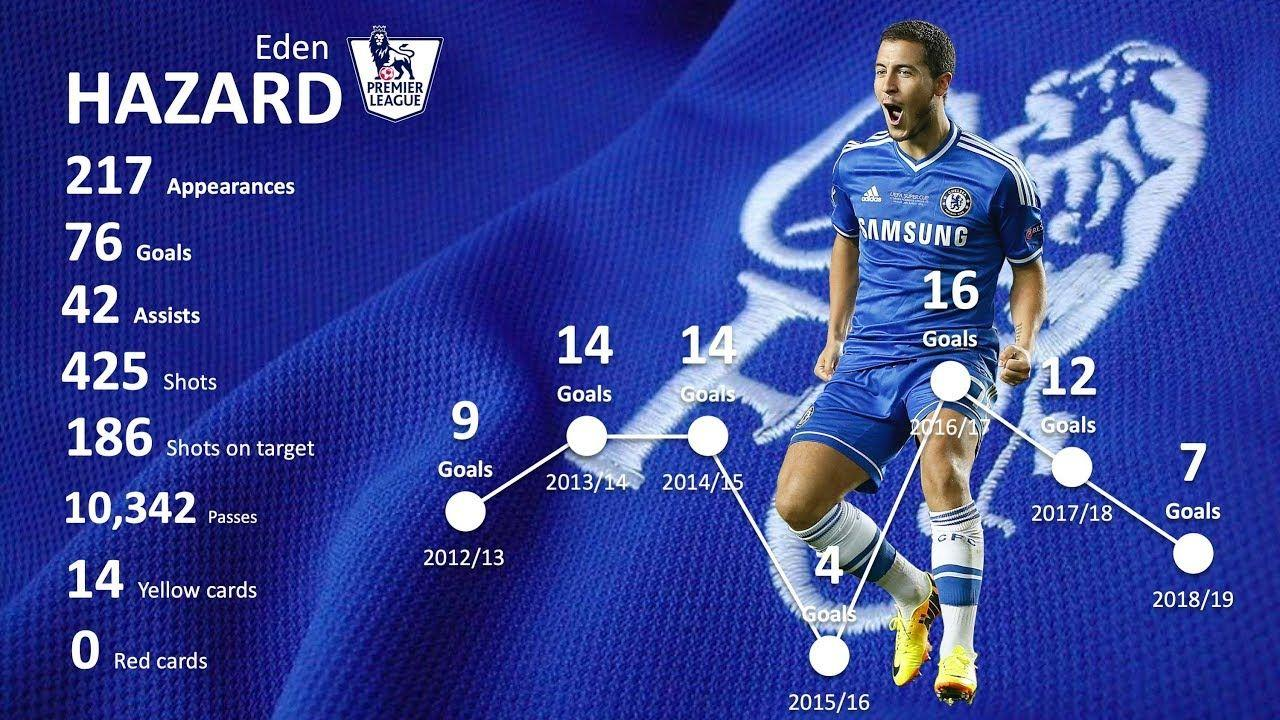Specify some key components in this picture. The player's jersey color is blue. The player's shoe is colored yellow. 